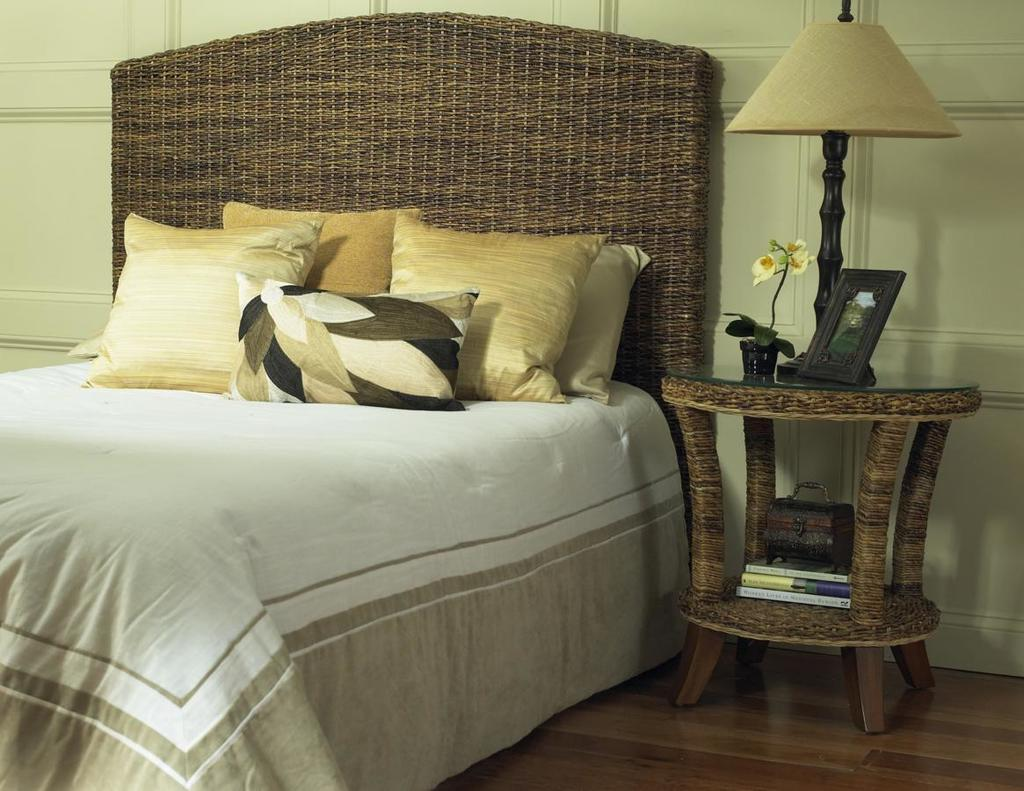What type of furniture is present in the image? There is a bed and a table in the image. What items can be seen on the bed? There are pillows on the bed. What type of lighting is present in the image? There is a bed lamp in the image. What type of decorative item is present in the image? There is a photo frame in the image. What type of living organism is present in the image? There is a plant in the image. Can you tell me how many chess pieces are on the table in the image? There is no chess set present on the table in the image. What type of animal is depicted in the photo frame in the image? There is no animal depicted in the photo frame in the image. 